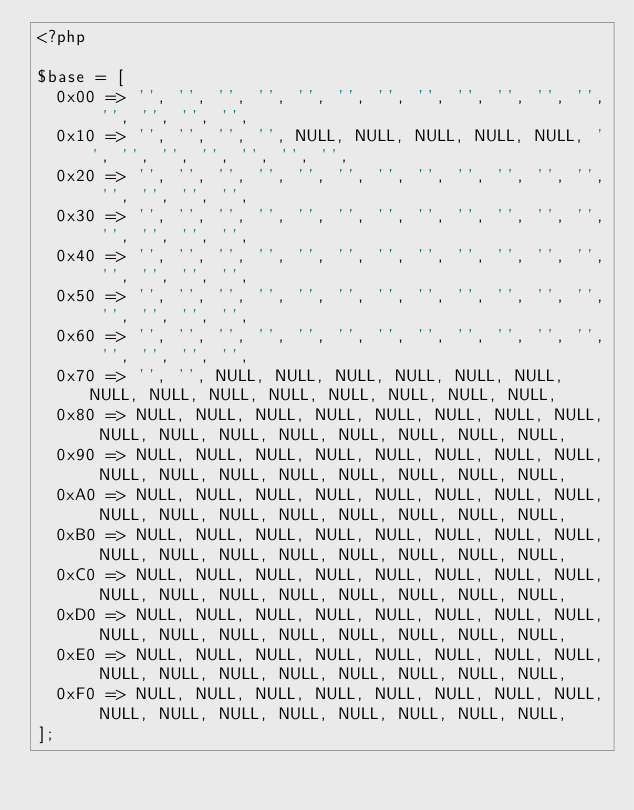Convert code to text. <code><loc_0><loc_0><loc_500><loc_500><_PHP_><?php

$base = [
  0x00 => '', '', '', '', '', '', '', '', '', '', '', '', '', '', '', '',
  0x10 => '', '', '', '', NULL, NULL, NULL, NULL, NULL, '', '', '', '', '', '', '',
  0x20 => '', '', '', '', '', '', '', '', '', '', '', '', '', '', '', '',
  0x30 => '', '', '', '', '', '', '', '', '', '', '', '', '', '', '', '',
  0x40 => '', '', '', '', '', '', '', '', '', '', '', '', '', '', '', '',
  0x50 => '', '', '', '', '', '', '', '', '', '', '', '', '', '', '', '',
  0x60 => '', '', '', '', '', '', '', '', '', '', '', '', '', '', '', '',
  0x70 => '', '', NULL, NULL, NULL, NULL, NULL, NULL, NULL, NULL, NULL, NULL, NULL, NULL, NULL, NULL,
  0x80 => NULL, NULL, NULL, NULL, NULL, NULL, NULL, NULL, NULL, NULL, NULL, NULL, NULL, NULL, NULL, NULL,
  0x90 => NULL, NULL, NULL, NULL, NULL, NULL, NULL, NULL, NULL, NULL, NULL, NULL, NULL, NULL, NULL, NULL,
  0xA0 => NULL, NULL, NULL, NULL, NULL, NULL, NULL, NULL, NULL, NULL, NULL, NULL, NULL, NULL, NULL, NULL,
  0xB0 => NULL, NULL, NULL, NULL, NULL, NULL, NULL, NULL, NULL, NULL, NULL, NULL, NULL, NULL, NULL, NULL,
  0xC0 => NULL, NULL, NULL, NULL, NULL, NULL, NULL, NULL, NULL, NULL, NULL, NULL, NULL, NULL, NULL, NULL,
  0xD0 => NULL, NULL, NULL, NULL, NULL, NULL, NULL, NULL, NULL, NULL, NULL, NULL, NULL, NULL, NULL, NULL,
  0xE0 => NULL, NULL, NULL, NULL, NULL, NULL, NULL, NULL, NULL, NULL, NULL, NULL, NULL, NULL, NULL, NULL,
  0xF0 => NULL, NULL, NULL, NULL, NULL, NULL, NULL, NULL, NULL, NULL, NULL, NULL, NULL, NULL, NULL, NULL,
];
</code> 